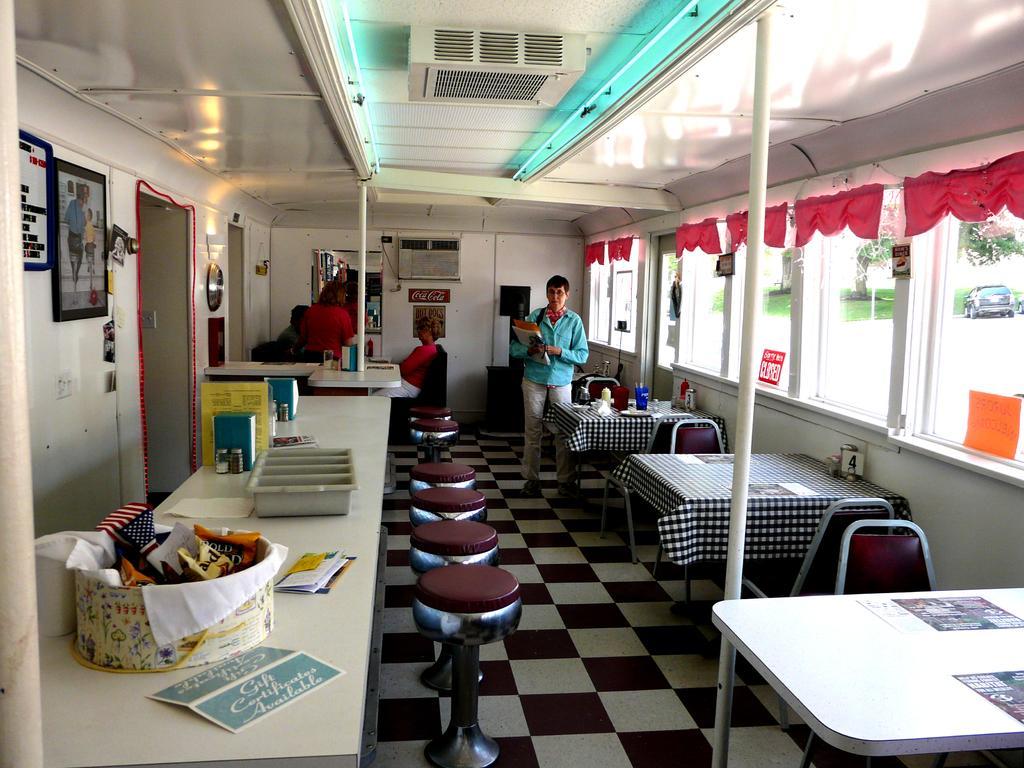Describe this image in one or two sentences. In this picture we can observe brown colored stools, chairs and tables. On the right side we can observe windows. There is a car on the road. We can observe a tree in the background. In the background there are some people in this room. On the left side we can observe a door. There are some photo frames fixed to the wall. 